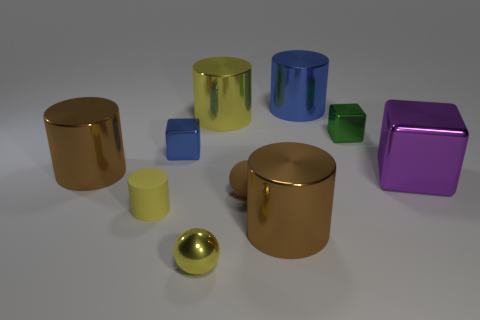There is a green shiny thing that is the same shape as the purple thing; what size is it?
Ensure brevity in your answer.  Small. Is there anything else that is the same size as the green shiny thing?
Your answer should be compact. Yes. Is the green shiny thing the same shape as the big yellow thing?
Your answer should be very brief. No. Is the number of yellow shiny cylinders right of the green metallic thing less than the number of big brown metal things that are on the right side of the rubber cylinder?
Keep it short and to the point. Yes. There is a blue cylinder; how many blue objects are in front of it?
Your response must be concise. 1. Is the shape of the big object that is in front of the small yellow cylinder the same as the blue metal thing left of the brown ball?
Your answer should be compact. No. What number of other objects are the same color as the tiny cylinder?
Provide a succinct answer. 2. What is the material of the brown cylinder on the left side of the big brown cylinder right of the yellow cylinder that is in front of the tiny green thing?
Offer a terse response. Metal. What is the material of the tiny cube that is to the right of the blue object on the right side of the small metal ball?
Make the answer very short. Metal. Are there fewer big metallic things in front of the metal sphere than tiny yellow spheres?
Make the answer very short. Yes. 